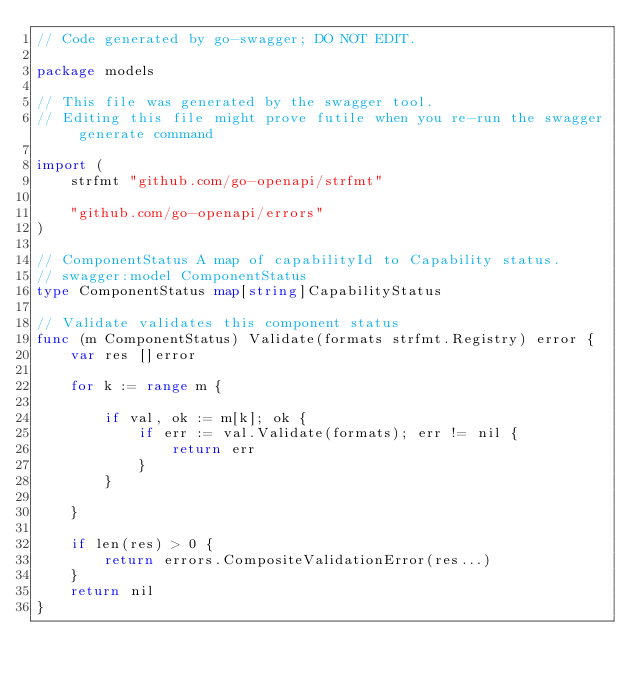Convert code to text. <code><loc_0><loc_0><loc_500><loc_500><_Go_>// Code generated by go-swagger; DO NOT EDIT.

package models

// This file was generated by the swagger tool.
// Editing this file might prove futile when you re-run the swagger generate command

import (
	strfmt "github.com/go-openapi/strfmt"

	"github.com/go-openapi/errors"
)

// ComponentStatus A map of capabilityId to Capability status.
// swagger:model ComponentStatus
type ComponentStatus map[string]CapabilityStatus

// Validate validates this component status
func (m ComponentStatus) Validate(formats strfmt.Registry) error {
	var res []error

	for k := range m {

		if val, ok := m[k]; ok {
			if err := val.Validate(formats); err != nil {
				return err
			}
		}

	}

	if len(res) > 0 {
		return errors.CompositeValidationError(res...)
	}
	return nil
}
</code> 